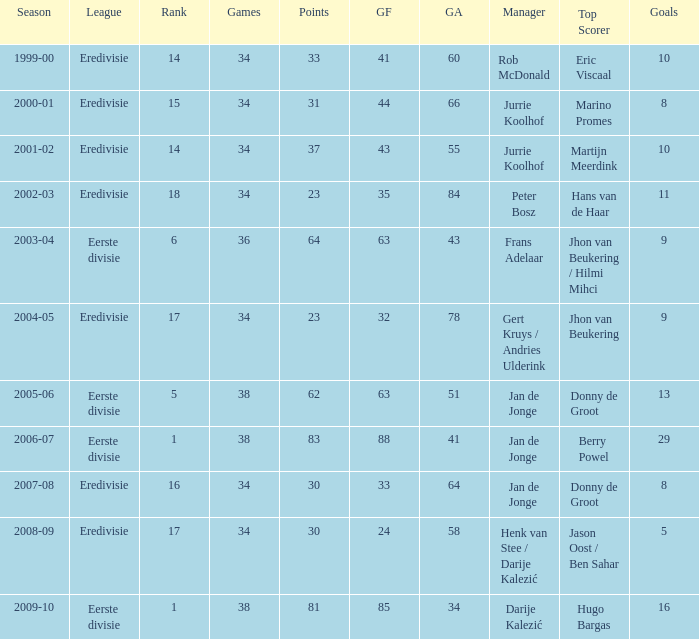What was the total number of goals scored during the 2005-06 season? 13.0. 